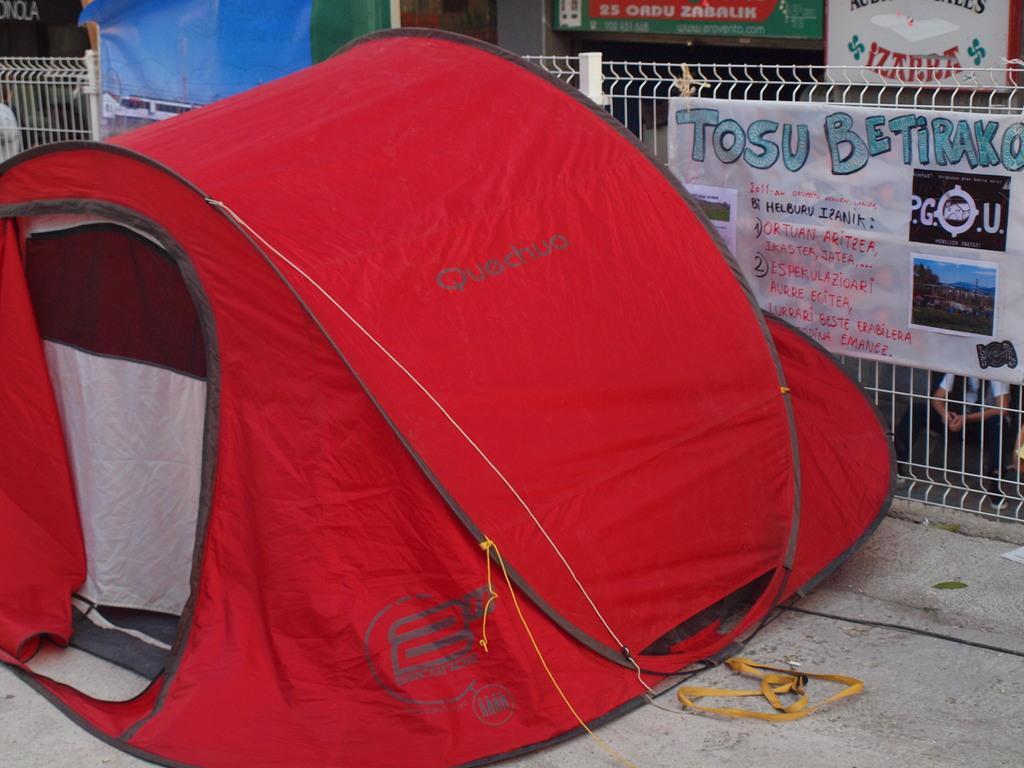In one or two sentences, can you explain what this image depicts? It is a tent which is in red color, on the right side it is an iron grill. 